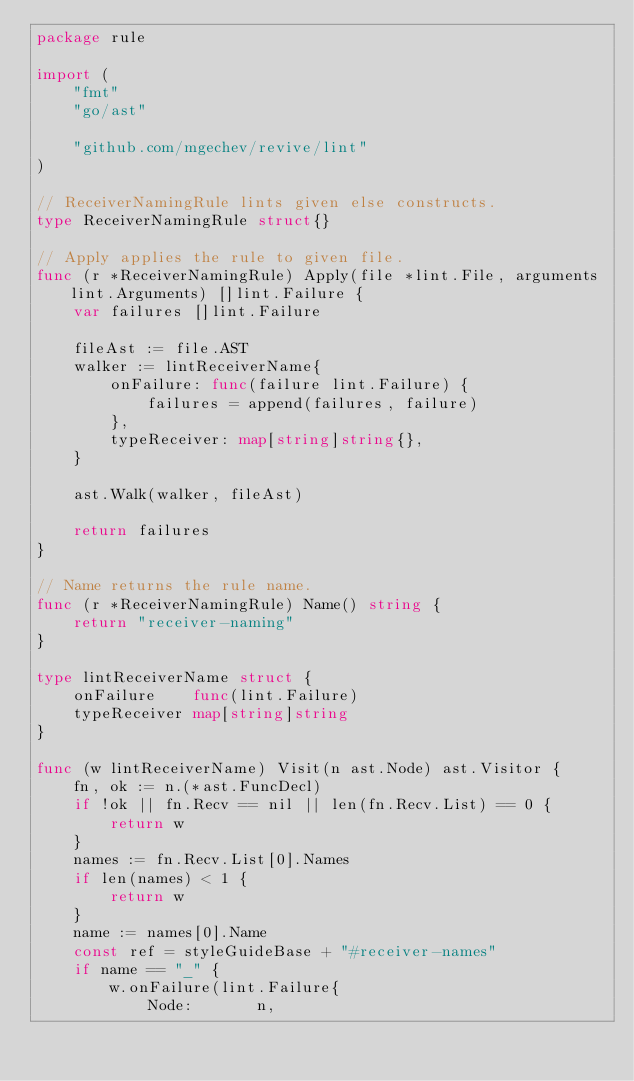Convert code to text. <code><loc_0><loc_0><loc_500><loc_500><_Go_>package rule

import (
	"fmt"
	"go/ast"

	"github.com/mgechev/revive/lint"
)

// ReceiverNamingRule lints given else constructs.
type ReceiverNamingRule struct{}

// Apply applies the rule to given file.
func (r *ReceiverNamingRule) Apply(file *lint.File, arguments lint.Arguments) []lint.Failure {
	var failures []lint.Failure

	fileAst := file.AST
	walker := lintReceiverName{
		onFailure: func(failure lint.Failure) {
			failures = append(failures, failure)
		},
		typeReceiver: map[string]string{},
	}

	ast.Walk(walker, fileAst)

	return failures
}

// Name returns the rule name.
func (r *ReceiverNamingRule) Name() string {
	return "receiver-naming"
}

type lintReceiverName struct {
	onFailure    func(lint.Failure)
	typeReceiver map[string]string
}

func (w lintReceiverName) Visit(n ast.Node) ast.Visitor {
	fn, ok := n.(*ast.FuncDecl)
	if !ok || fn.Recv == nil || len(fn.Recv.List) == 0 {
		return w
	}
	names := fn.Recv.List[0].Names
	if len(names) < 1 {
		return w
	}
	name := names[0].Name
	const ref = styleGuideBase + "#receiver-names"
	if name == "_" {
		w.onFailure(lint.Failure{
			Node:       n,</code> 